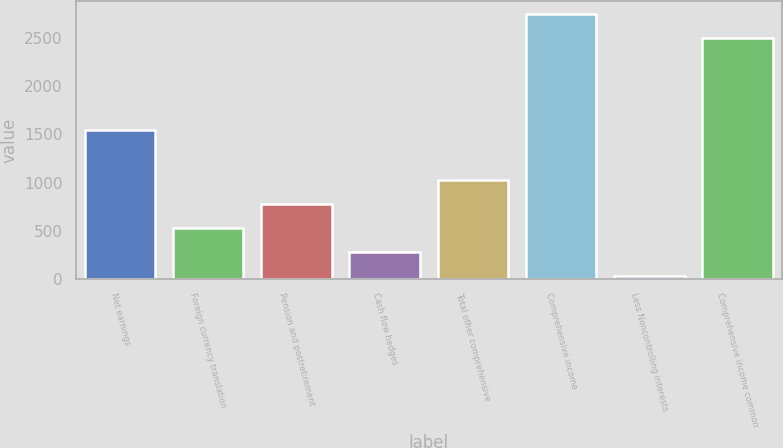<chart> <loc_0><loc_0><loc_500><loc_500><bar_chart><fcel>Net earnings<fcel>Foreign currency translation<fcel>Pension and postretirement<fcel>Cash flow hedges<fcel>Total other comprehensive<fcel>Comprehensive income<fcel>Less Noncontrolling interests<fcel>Comprehensive income common<nl><fcel>1550<fcel>529.6<fcel>779.4<fcel>279.8<fcel>1029.2<fcel>2747.8<fcel>30<fcel>2498<nl></chart> 